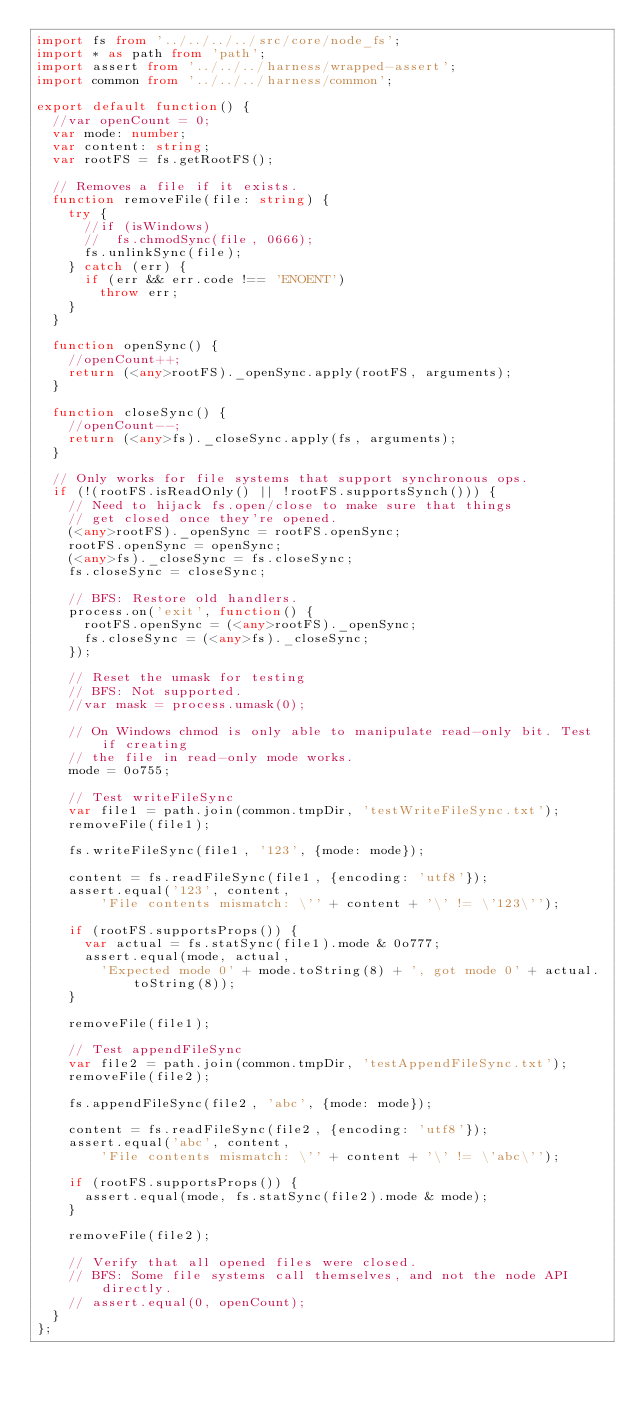<code> <loc_0><loc_0><loc_500><loc_500><_TypeScript_>import fs from '../../../../src/core/node_fs';
import * as path from 'path';
import assert from '../../../harness/wrapped-assert';
import common from '../../../harness/common';

export default function() {
  //var openCount = 0;
  var mode: number;
  var content: string;
  var rootFS = fs.getRootFS();

  // Removes a file if it exists.
  function removeFile(file: string) {
    try {
      //if (isWindows)
      //  fs.chmodSync(file, 0666);
      fs.unlinkSync(file);
    } catch (err) {
      if (err && err.code !== 'ENOENT')
        throw err;
    }
  }

  function openSync() {
    //openCount++;
    return (<any>rootFS)._openSync.apply(rootFS, arguments);
  }

  function closeSync() {
    //openCount--;
    return (<any>fs)._closeSync.apply(fs, arguments);
  }

  // Only works for file systems that support synchronous ops.
  if (!(rootFS.isReadOnly() || !rootFS.supportsSynch())) {
    // Need to hijack fs.open/close to make sure that things
    // get closed once they're opened.
    (<any>rootFS)._openSync = rootFS.openSync;
    rootFS.openSync = openSync;
    (<any>fs)._closeSync = fs.closeSync;
    fs.closeSync = closeSync;

    // BFS: Restore old handlers.
    process.on('exit', function() {
      rootFS.openSync = (<any>rootFS)._openSync;
      fs.closeSync = (<any>fs)._closeSync;
    });

    // Reset the umask for testing
    // BFS: Not supported.
    //var mask = process.umask(0);

    // On Windows chmod is only able to manipulate read-only bit. Test if creating
    // the file in read-only mode works.
    mode = 0o755;

    // Test writeFileSync
    var file1 = path.join(common.tmpDir, 'testWriteFileSync.txt');
    removeFile(file1);

    fs.writeFileSync(file1, '123', {mode: mode});

    content = fs.readFileSync(file1, {encoding: 'utf8'});
    assert.equal('123', content,
        'File contents mismatch: \'' + content + '\' != \'123\'');

    if (rootFS.supportsProps()) {
      var actual = fs.statSync(file1).mode & 0o777;
      assert.equal(mode, actual,
        'Expected mode 0' + mode.toString(8) + ', got mode 0' + actual.toString(8));
    }

    removeFile(file1);

    // Test appendFileSync
    var file2 = path.join(common.tmpDir, 'testAppendFileSync.txt');
    removeFile(file2);

    fs.appendFileSync(file2, 'abc', {mode: mode});

    content = fs.readFileSync(file2, {encoding: 'utf8'});
    assert.equal('abc', content,
        'File contents mismatch: \'' + content + '\' != \'abc\'');

    if (rootFS.supportsProps()) {
      assert.equal(mode, fs.statSync(file2).mode & mode);
    }

    removeFile(file2);

    // Verify that all opened files were closed.
    // BFS: Some file systems call themselves, and not the node API directly.
    // assert.equal(0, openCount);
  }
};
</code> 